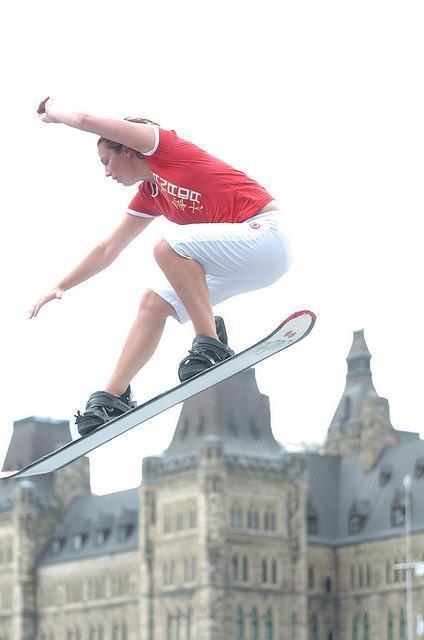How many vans follows the bus in a given image?
Give a very brief answer. 0. 